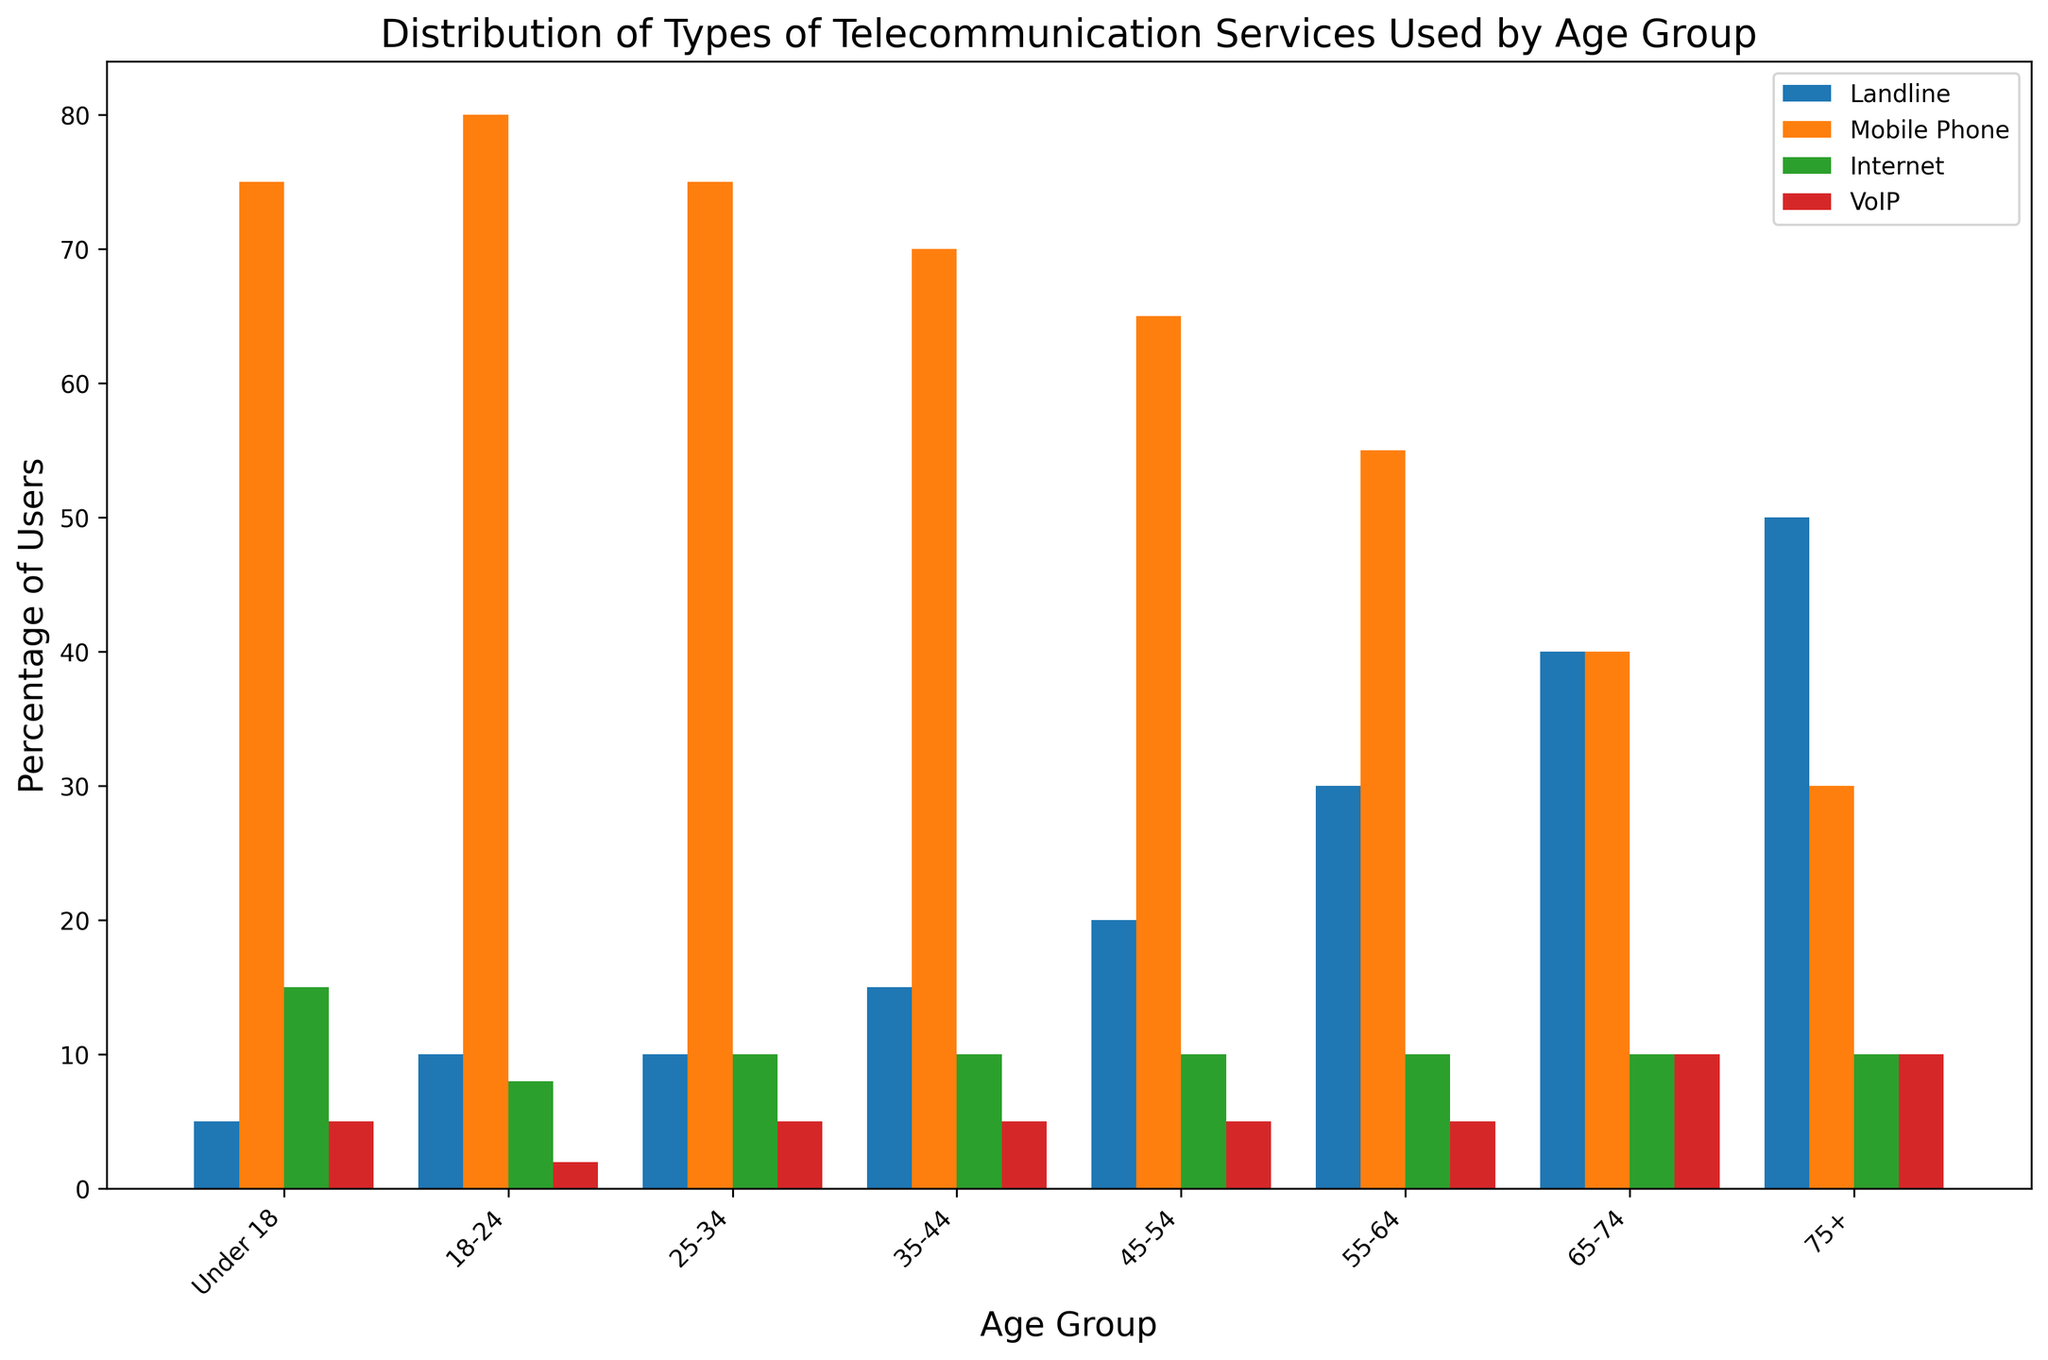What age group has the highest percentage of mobile phone users? The highest bar for mobile phones is in the age group 18-24.
Answer: 18-24 Which telecommunication service is most used by the 65-74 age group? The tallest bar in the 65-74 age group's set is for Landline.
Answer: Landline Compare the percentage of Internet users between the Under 18 and 75+ age groups. Which is higher? The Under 18 and 75+ age groups both have an equal percentage of Internet users, visualized by bars of the same height.
Answer: Equal What is the difference in landline use between the 35-44 and 75+ age groups? The percentages are 15 for 35-44 and 50 for 75+. Subtracting these gives 50 - 15.
Answer: 35 How does VoIP usage in the 55-64 age group compare to the 75+ age group? Both age groups have VoIP usage percentage of 10, visualized by bars of the same height.
Answer: Equal Which age group has the least percentage of mobile phone users? The age group with the lowest mobile phone usage percentage (visualized by the shortest bar) is the 75+ age group.
Answer: 75+ What is the total percentage of landline users across all age groups? Adding up the percentages for Landline across all age groups: 5 + 10 + 10 + 15 + 20 + 30 + 40 + 50.
Answer: 180 Which color represents the VoIP telecommunication service in the chart? The VoIP service is represented by the color red.
Answer: Red In which age group is Internet usage least prevalent, and what is that percentage? The age group 18-24 has the least Internet usage at 8%, visualized by the shortest bar for Internet.
Answer: 18-24, 8% By how much does landline usage in the 55-64 age group exceed mobile phone usage in the same group? The 55-64 age group has 30% landline users and 55% mobile phone users; subtracting these gives 30 - 55.
Answer: -25 What percentage of users in the 25-34 age group use Internet? The Internet usage for the 25-34 age group is 10%, visible by the height of the Internet bar.
Answer: 10 